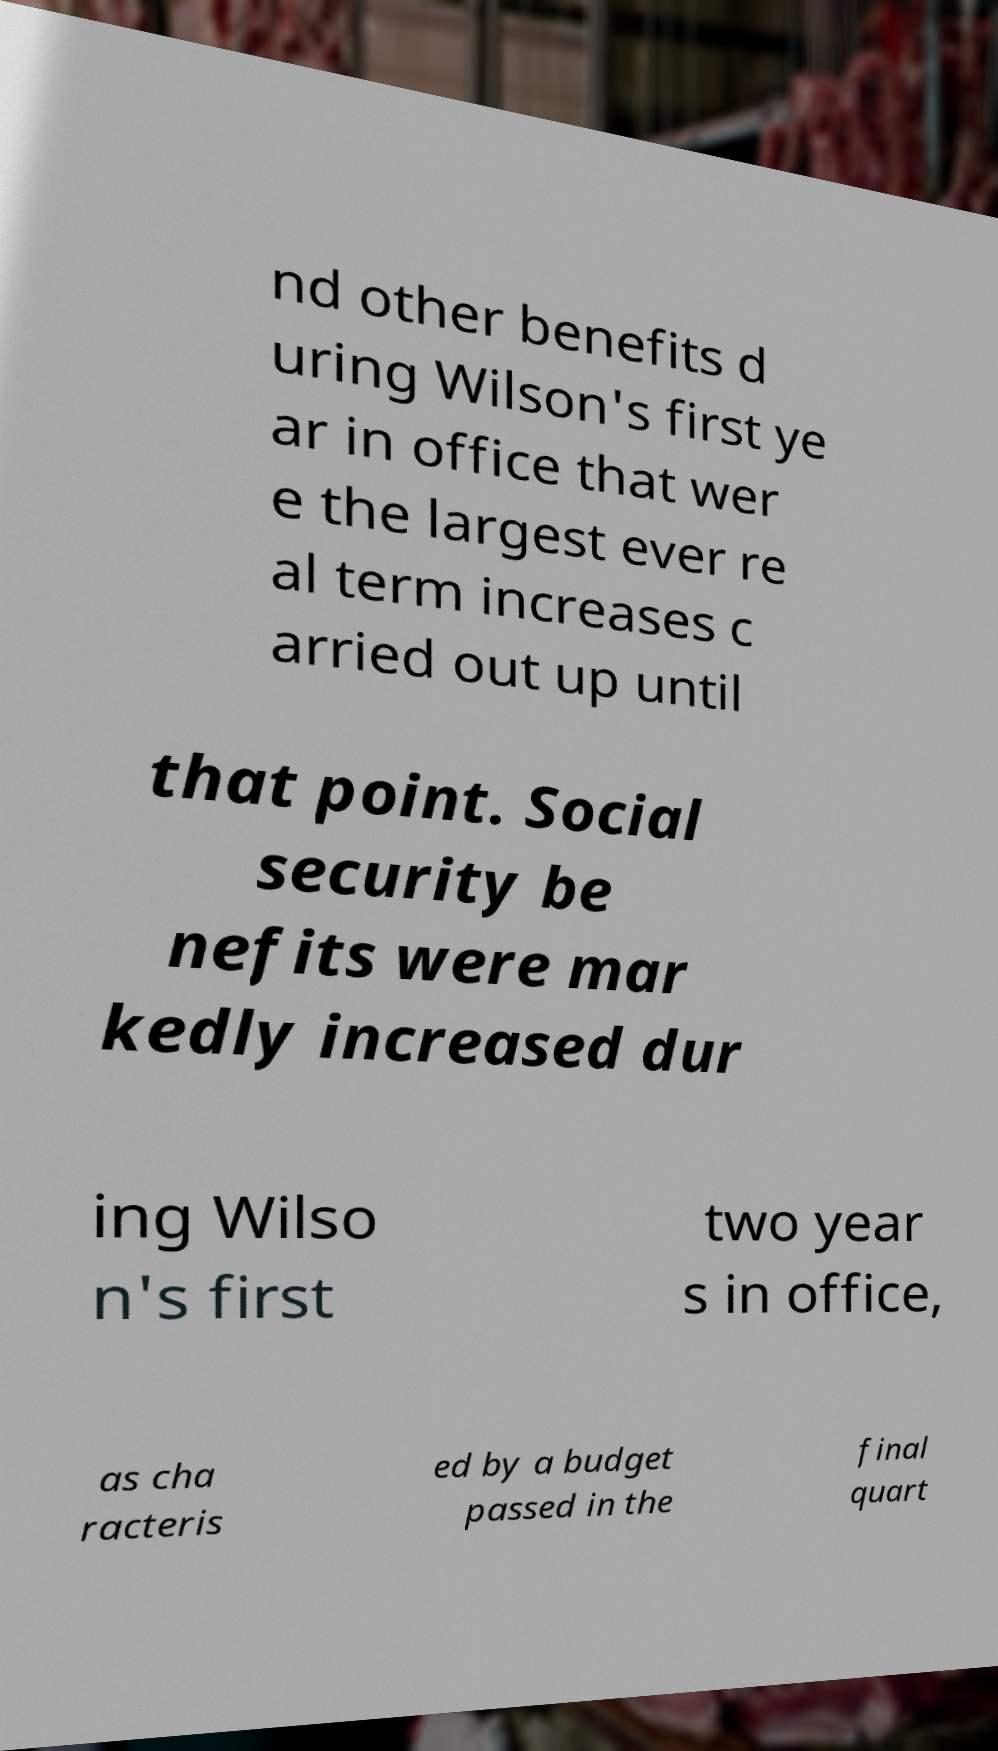Could you extract and type out the text from this image? nd other benefits d uring Wilson's first ye ar in office that wer e the largest ever re al term increases c arried out up until that point. Social security be nefits were mar kedly increased dur ing Wilso n's first two year s in office, as cha racteris ed by a budget passed in the final quart 